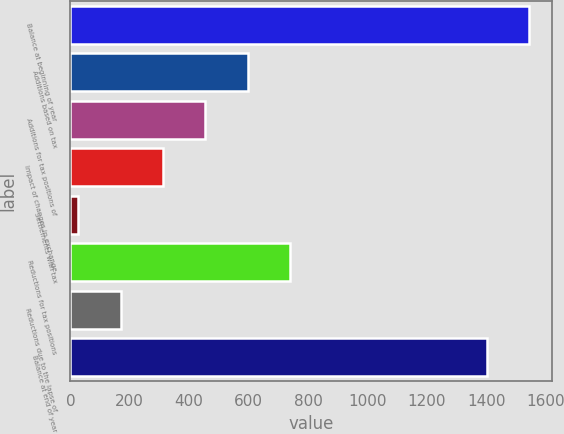<chart> <loc_0><loc_0><loc_500><loc_500><bar_chart><fcel>Balance at beginning of year<fcel>Additions based on tax<fcel>Additions for tax positions of<fcel>Impact of changes in exchange<fcel>Settlements with tax<fcel>Reductions for tax positions<fcel>Reductions due to the lapse of<fcel>Balance at end of year<nl><fcel>1544.5<fcel>597<fcel>454.5<fcel>312<fcel>27<fcel>739.5<fcel>169.5<fcel>1402<nl></chart> 